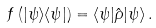Convert formula to latex. <formula><loc_0><loc_0><loc_500><loc_500>f \left ( | \psi \rangle \langle \psi | \right ) = \langle \psi | \hat { \rho } | \psi \rangle \, .</formula> 